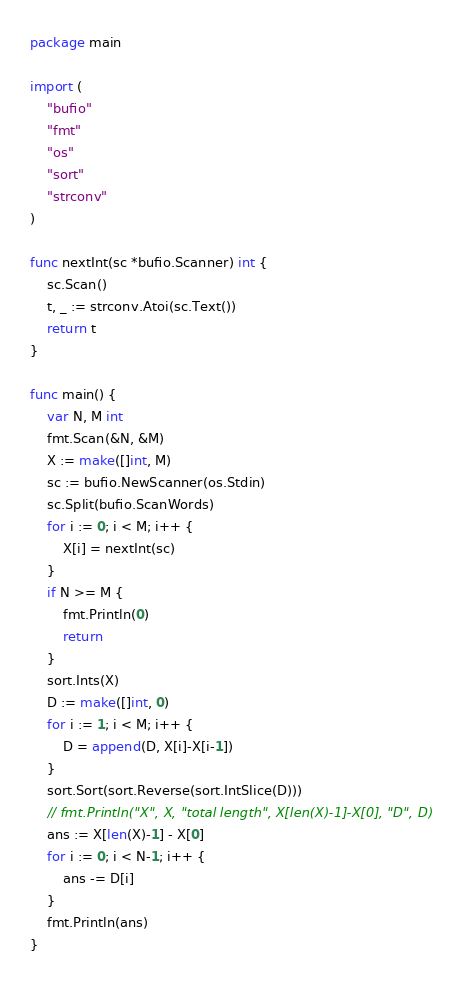Convert code to text. <code><loc_0><loc_0><loc_500><loc_500><_Go_>package main

import (
	"bufio"
	"fmt"
	"os"
	"sort"
	"strconv"
)

func nextInt(sc *bufio.Scanner) int {
	sc.Scan()
	t, _ := strconv.Atoi(sc.Text())
	return t
}

func main() {
	var N, M int
	fmt.Scan(&N, &M)
	X := make([]int, M)
	sc := bufio.NewScanner(os.Stdin)
	sc.Split(bufio.ScanWords)
	for i := 0; i < M; i++ {
		X[i] = nextInt(sc)
	}
	if N >= M {
		fmt.Println(0)
		return
	}
	sort.Ints(X)
	D := make([]int, 0)
	for i := 1; i < M; i++ {
		D = append(D, X[i]-X[i-1])
	}
	sort.Sort(sort.Reverse(sort.IntSlice(D)))
	// fmt.Println("X", X, "total length", X[len(X)-1]-X[0], "D", D)
	ans := X[len(X)-1] - X[0]
	for i := 0; i < N-1; i++ {
		ans -= D[i]
	}
	fmt.Println(ans)
}
</code> 